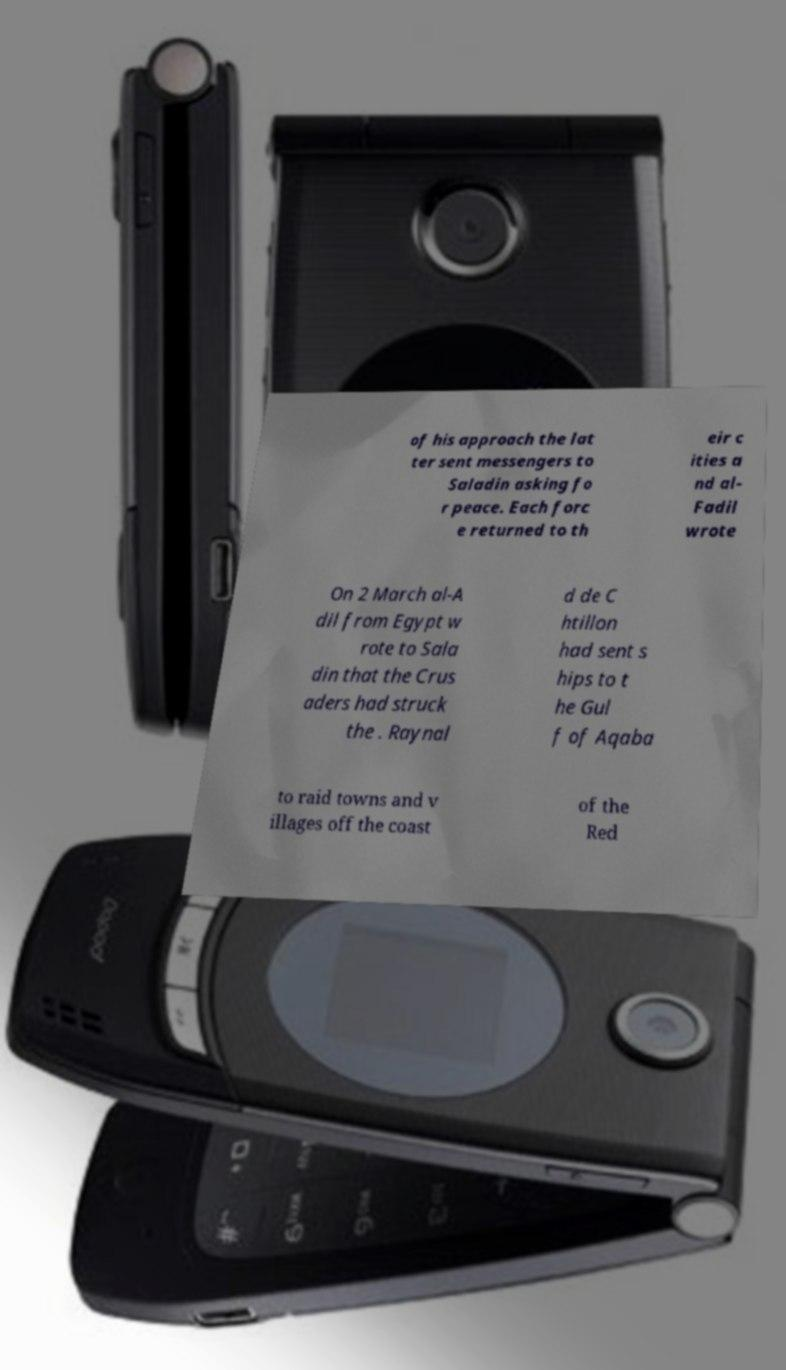I need the written content from this picture converted into text. Can you do that? of his approach the lat ter sent messengers to Saladin asking fo r peace. Each forc e returned to th eir c ities a nd al- Fadil wrote On 2 March al-A dil from Egypt w rote to Sala din that the Crus aders had struck the . Raynal d de C htillon had sent s hips to t he Gul f of Aqaba to raid towns and v illages off the coast of the Red 